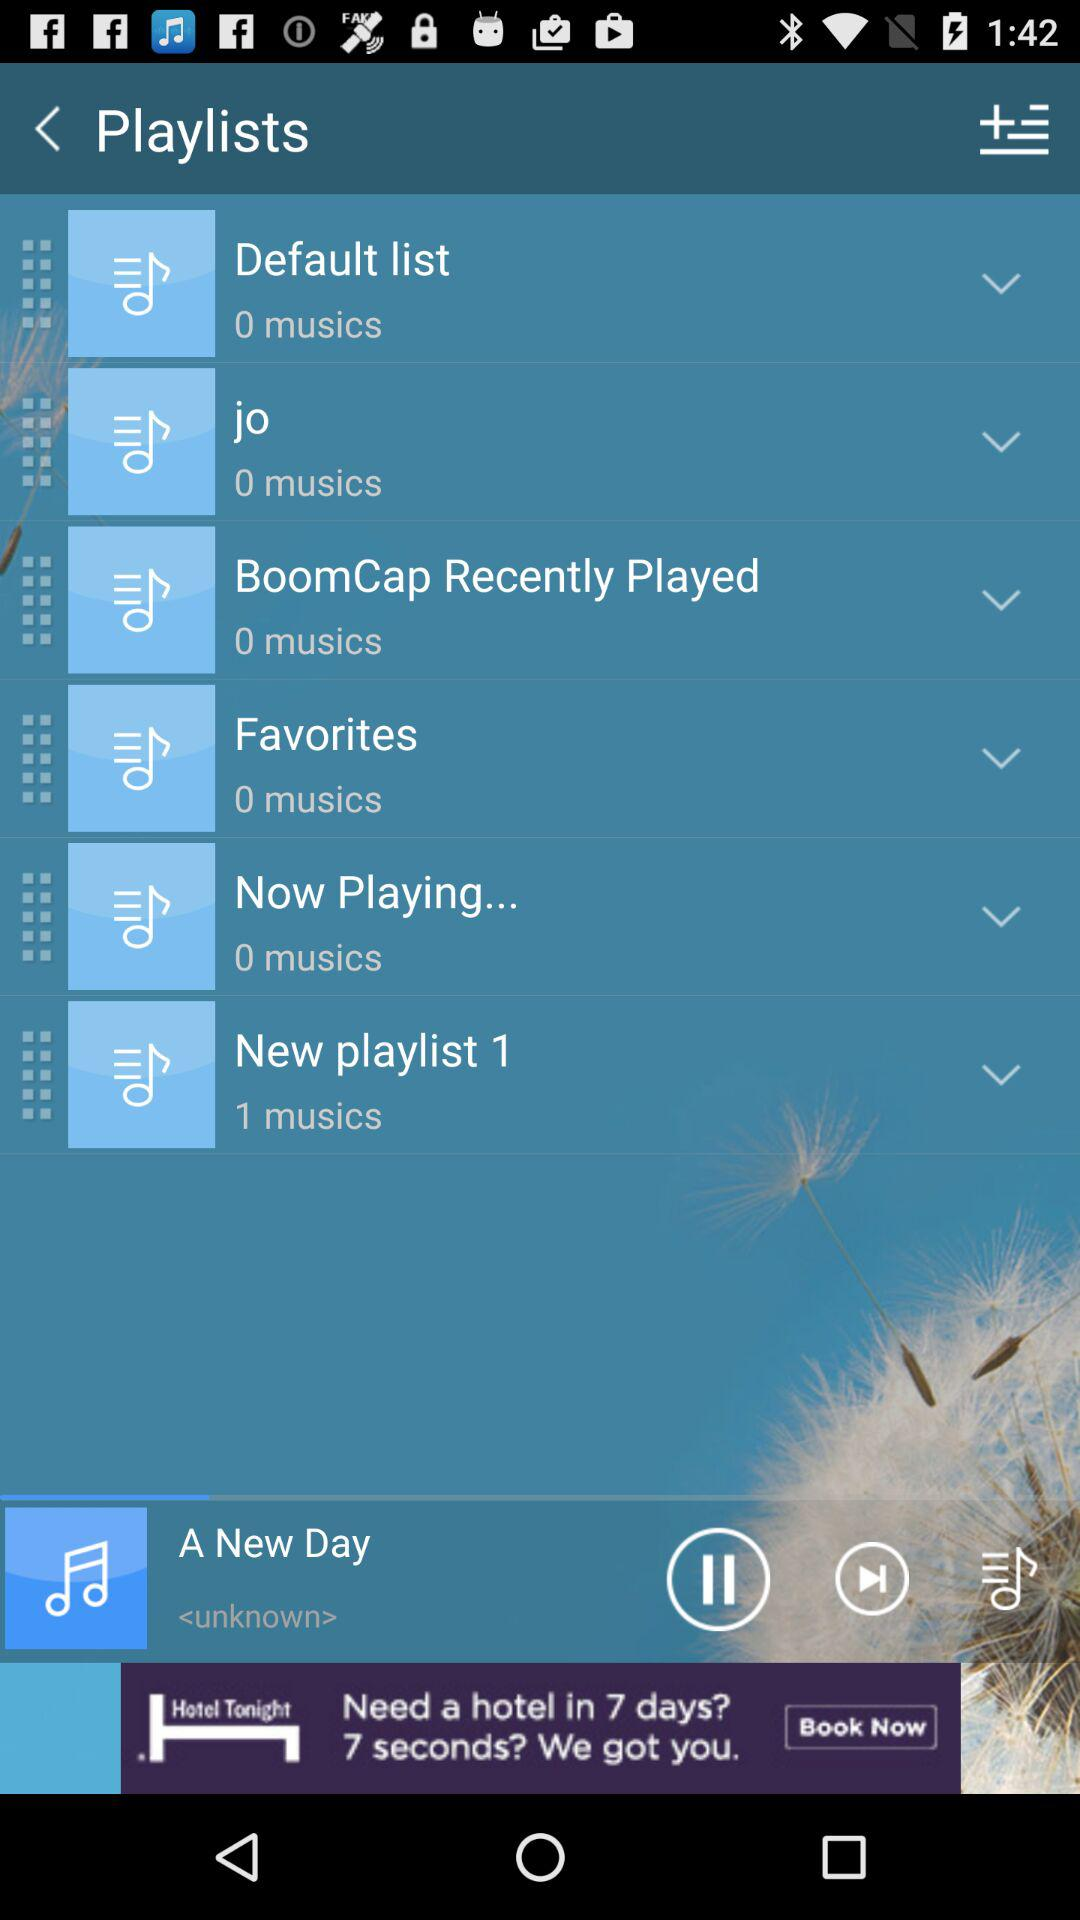Which song is playing? The song "A New Day" is playing. 